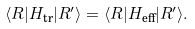<formula> <loc_0><loc_0><loc_500><loc_500>\langle R | H _ { \text {tr} } | R ^ { \prime } \rangle = \langle R | H _ { \text {eff} } | R ^ { \prime } \rangle .</formula> 